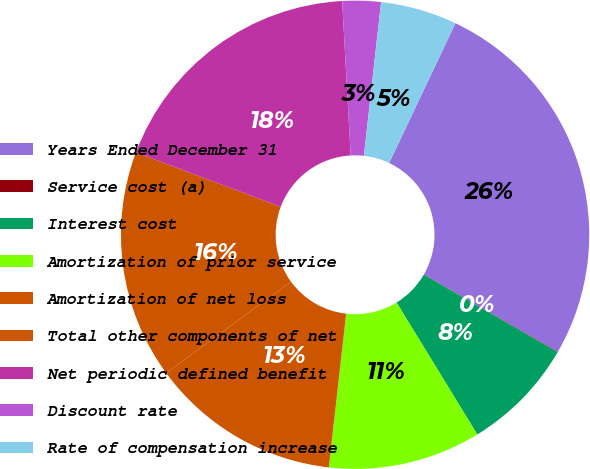Convert chart to OTSL. <chart><loc_0><loc_0><loc_500><loc_500><pie_chart><fcel>Years Ended December 31<fcel>Service cost (a)<fcel>Interest cost<fcel>Amortization of prior service<fcel>Amortization of net loss<fcel>Total other components of net<fcel>Net periodic defined benefit<fcel>Discount rate<fcel>Rate of compensation increase<nl><fcel>26.28%<fcel>0.03%<fcel>7.9%<fcel>10.53%<fcel>13.15%<fcel>15.78%<fcel>18.4%<fcel>2.65%<fcel>5.28%<nl></chart> 